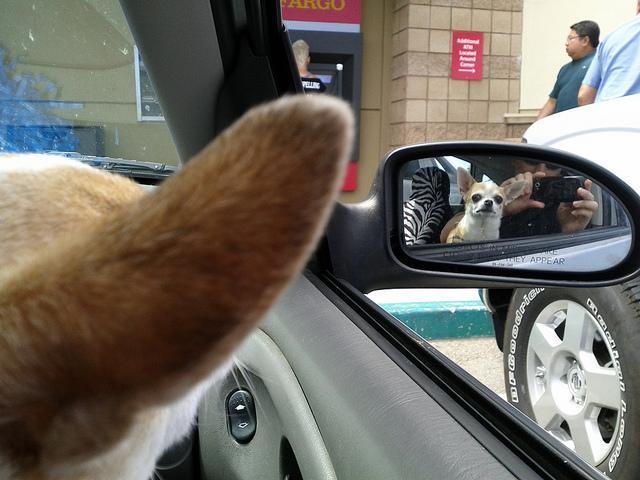How many wheels are visible?
Give a very brief answer. 1. How many dogs are visible?
Give a very brief answer. 2. How many people are there?
Give a very brief answer. 3. How many cars can be seen?
Give a very brief answer. 1. How many giraffes are pictured?
Give a very brief answer. 0. 